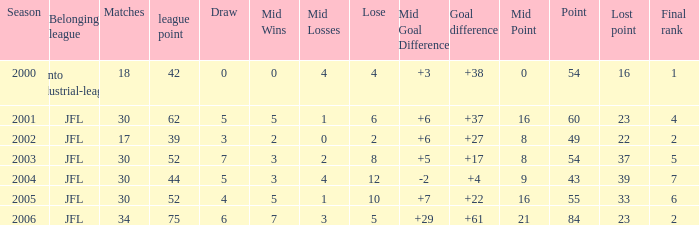Could you parse the entire table? {'header': ['Season', 'Belonging league', 'Matches', 'league point', 'Draw', 'Mid Wins', 'Mid Losses', 'Lose', 'Mid Goal Difference', 'Goal difference', 'Mid Point', 'Point', 'Lost point', 'Final rank'], 'rows': [['2000', 'Kanto industrial-league', '18', '42', '0', '0', '4', '4', '+3', '+38', '0', '54', '16', '1'], ['2001', 'JFL', '30', '62', '5', '5', '1', '6', '+6', '+37', '16', '60', '23', '4'], ['2002', 'JFL', '17', '39', '3', '2', '0', '2', '+6', '+27', '8', '49', '22', '2'], ['2003', 'JFL', '30', '52', '7', '3', '2', '8', '+5', '+17', '8', '54', '37', '5'], ['2004', 'JFL', '30', '44', '5', '3', '4', '12', '-2', '+4', '9', '43', '39', '7'], ['2005', 'JFL', '30', '52', '4', '5', '1', '10', '+7', '+22', '16', '55', '33', '6'], ['2006', 'JFL', '34', '75', '6', '7', '3', '5', '+29', '+61', '21', '84', '23', '2']]} Identify the highest-scoring matches for point 43 that have a final rank of less than 7. None. 